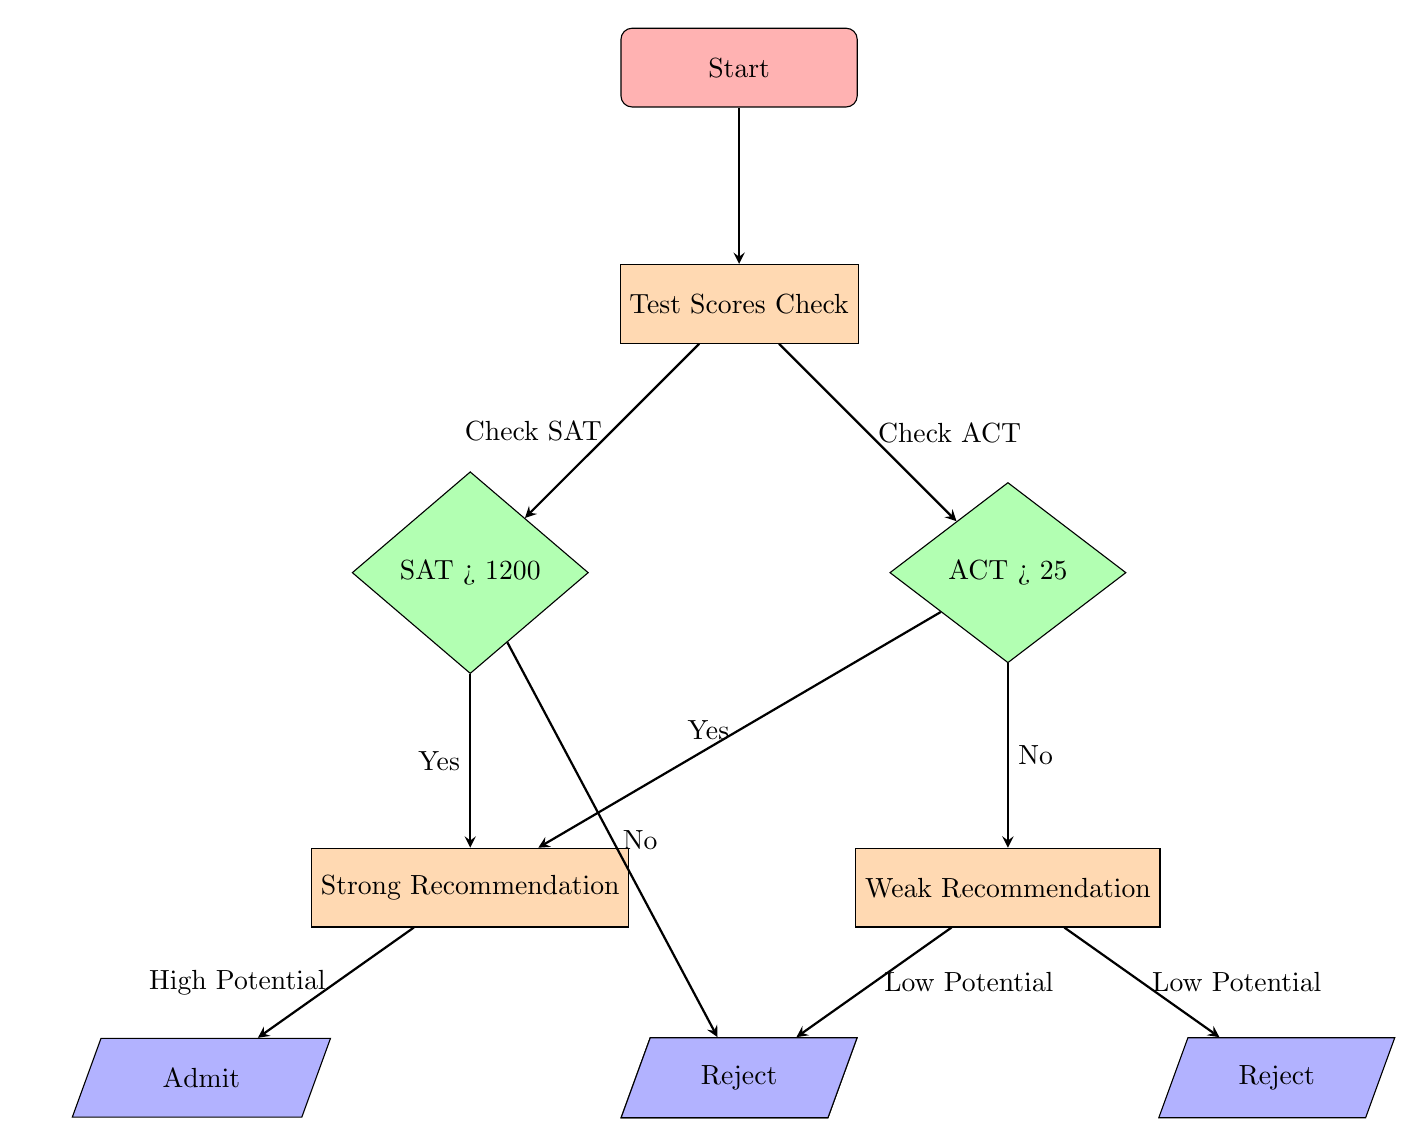What is the first action in the diagram? The diagram starts with the node labeled "Start," which indicates the beginning of the process.
Answer: Start How many decisions are made in the process? There are two decision nodes in the diagram: one for SAT scores and one for ACT scores, making a total of two decisions.
Answer: 2 What happens if a student's SAT score is greater than 1200? If the SAT score is greater than 1200, the flow moves to the process labeled "Strong Recommendation."
Answer: Strong Recommendation What is the output if a student's ACT score is greater than 25? If the ACT score is greater than 25, the diagram leads to the same "Strong Recommendation" process as having a high SAT score.
Answer: Strong Recommendation What occurs if a student lacks strong potential? If a student is determined to have low potential, they are directed to the "Reject" node, leading to potential rejection of their admission.
Answer: Reject What action follows a strong recommendation? After a strong recommendation, the next step in the flow is to "Admit" the student if they demonstrate high potential.
Answer: Admit If both tests indicate low scores, what is the outcome? In this case, the flow leads to two separate rejection nodes labeled "Reject," indicating that low scores on both tests result in rejection.
Answer: Reject Which node appears after evaluating the ACT score? After evaluating the ACT score, if it is determined to not meet the cutoff, the next node is the "Weak Recommendation" process.
Answer: Weak Recommendation What relationship exists between strong recommendation and admission? The strong recommendation directly leads to the action of admitting the student, which shows a positive outcome for high test scores.
Answer: Admit 